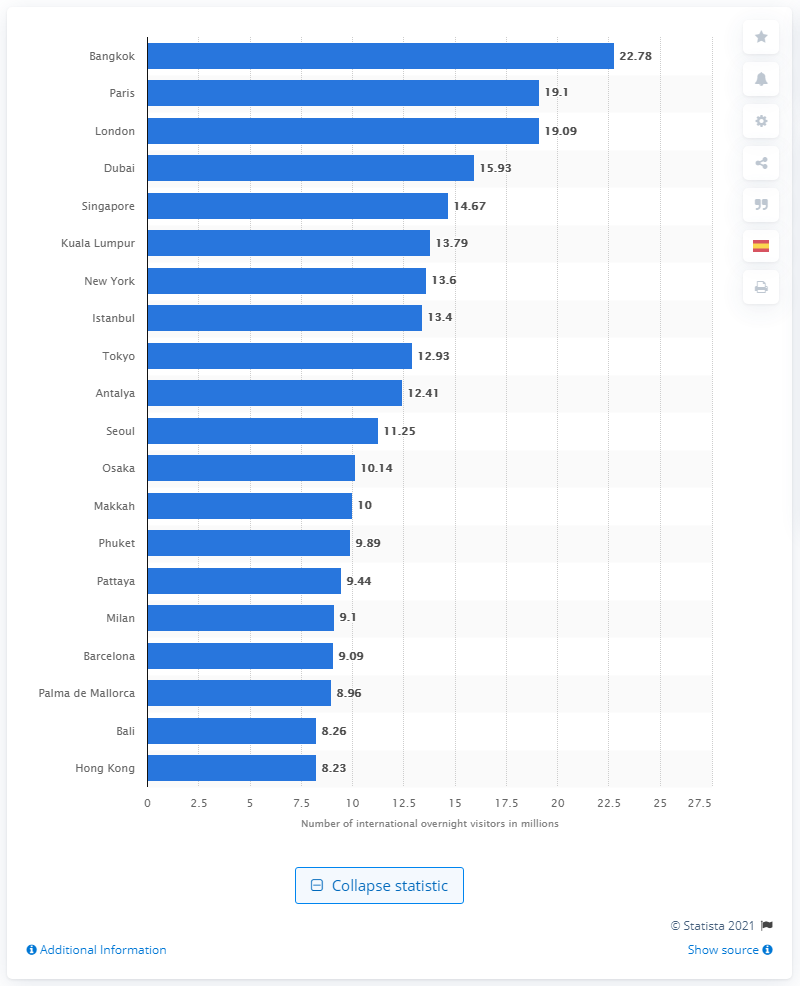List a handful of essential elements in this visual. In 2018, a total of 22,780 international overnight visitors came to Bangkok. 